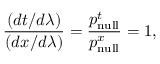<formula> <loc_0><loc_0><loc_500><loc_500>{ \frac { ( d t / d \lambda ) } { ( d x / d \lambda ) } } = { \frac { p _ { n u l l } ^ { t } } { p _ { n u l l } ^ { x } } } = 1 ,</formula> 